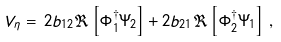Convert formula to latex. <formula><loc_0><loc_0><loc_500><loc_500>V _ { \eta } & = \, 2 b _ { 1 2 } \Re \left [ \Phi _ { 1 } ^ { \dagger } \Psi _ { 2 } \right ] + 2 b _ { 2 1 } \Re \left [ \Phi _ { 2 } ^ { \dagger } \Psi _ { 1 } \right ] \, ,</formula> 